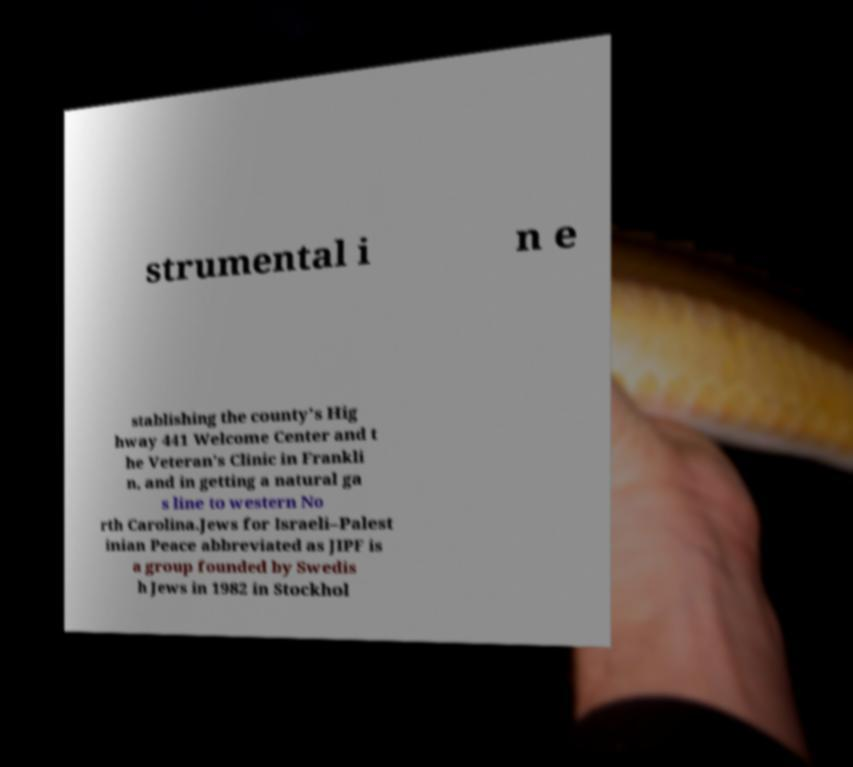Can you accurately transcribe the text from the provided image for me? strumental i n e stablishing the county's Hig hway 441 Welcome Center and t he Veteran's Clinic in Frankli n, and in getting a natural ga s line to western No rth Carolina.Jews for Israeli–Palest inian Peace abbreviated as JIPF is a group founded by Swedis h Jews in 1982 in Stockhol 